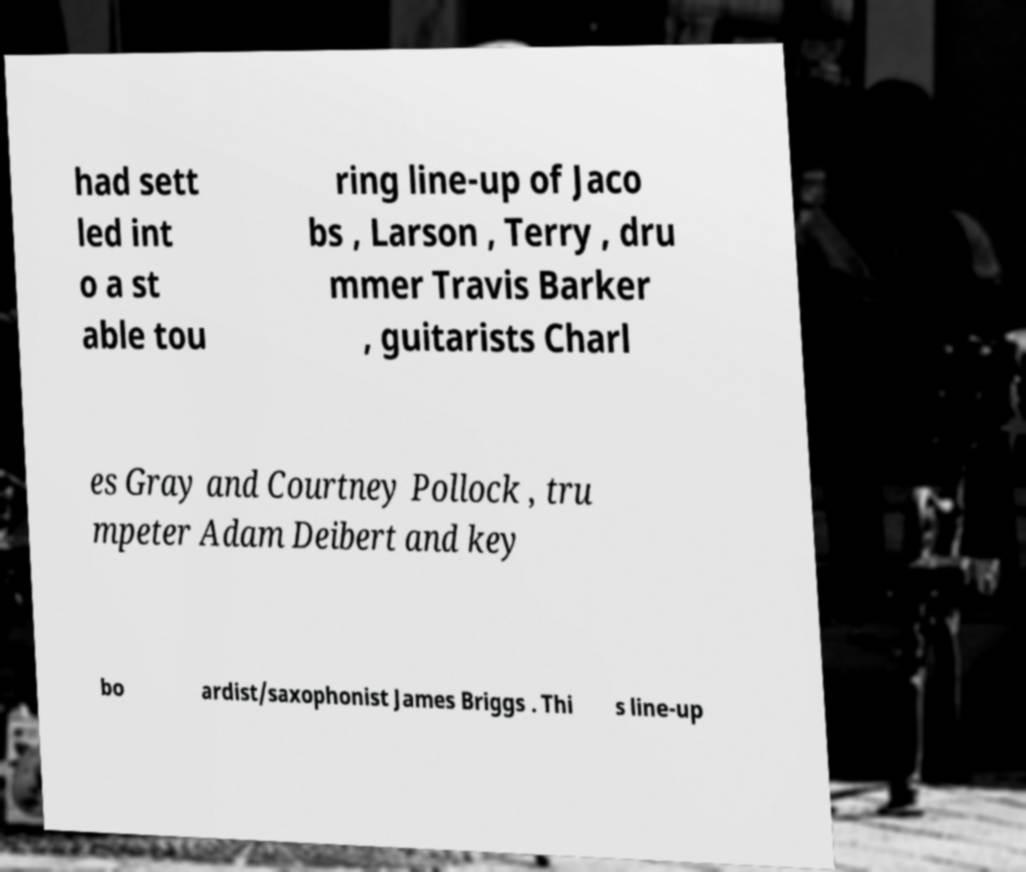Can you accurately transcribe the text from the provided image for me? had sett led int o a st able tou ring line-up of Jaco bs , Larson , Terry , dru mmer Travis Barker , guitarists Charl es Gray and Courtney Pollock , tru mpeter Adam Deibert and key bo ardist/saxophonist James Briggs . Thi s line-up 